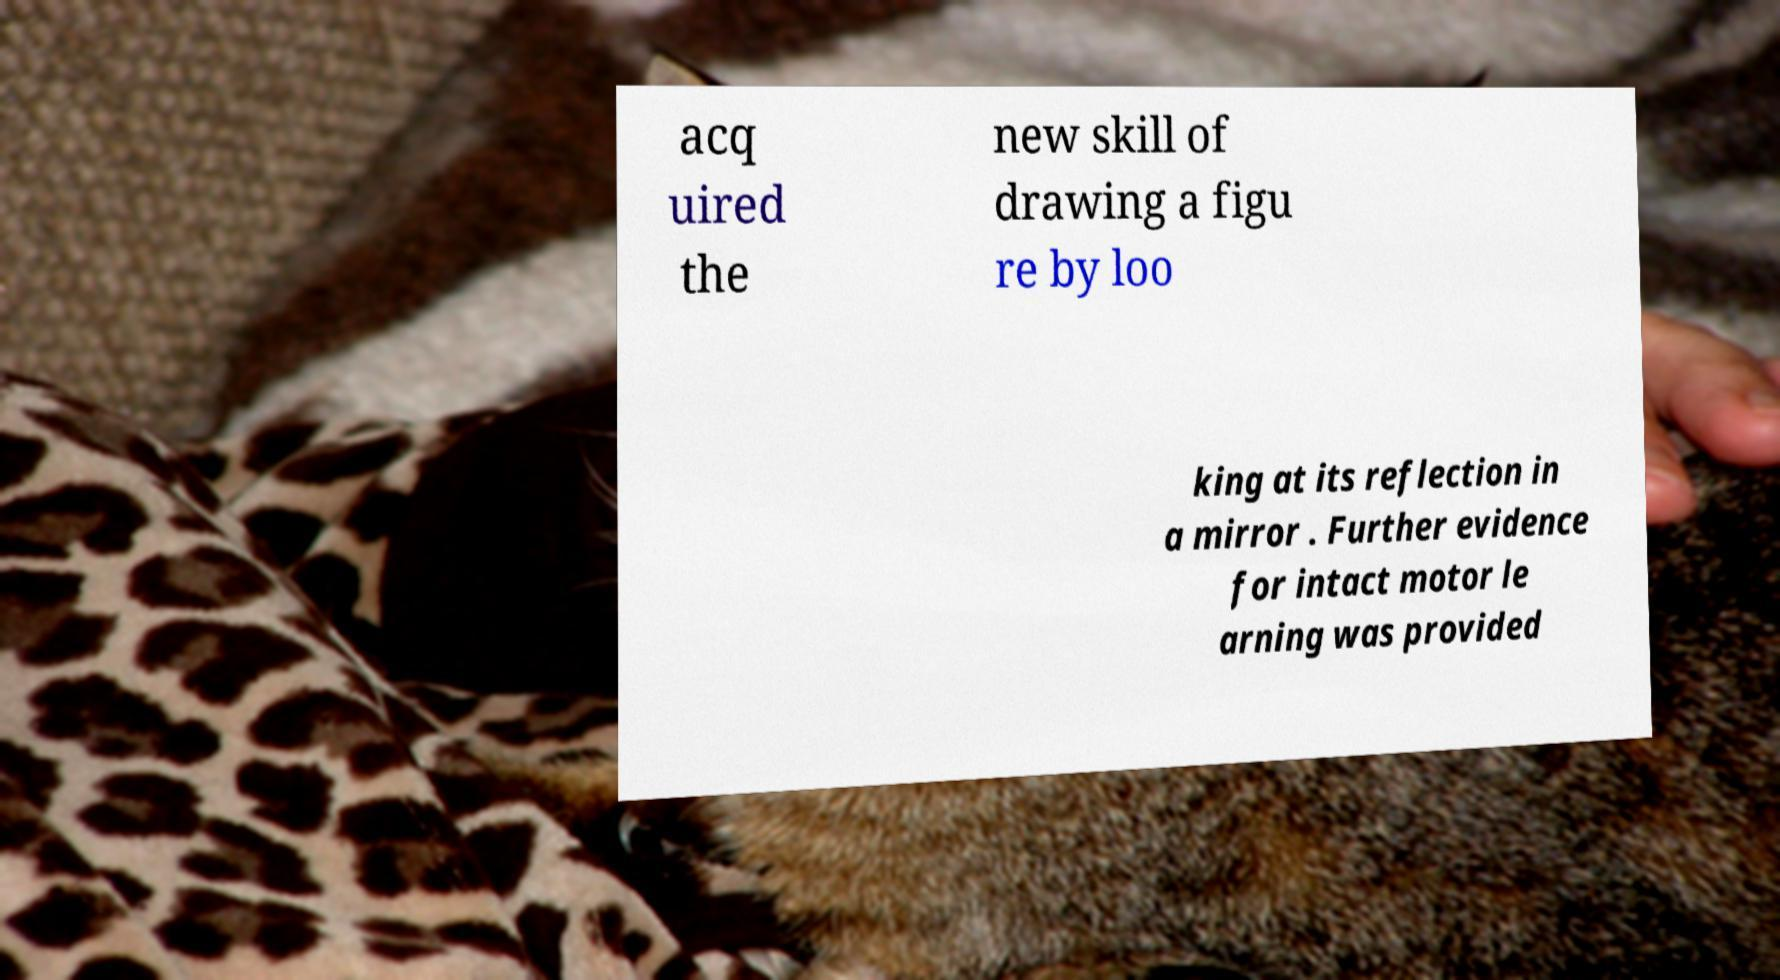I need the written content from this picture converted into text. Can you do that? acq uired the new skill of drawing a figu re by loo king at its reflection in a mirror . Further evidence for intact motor le arning was provided 